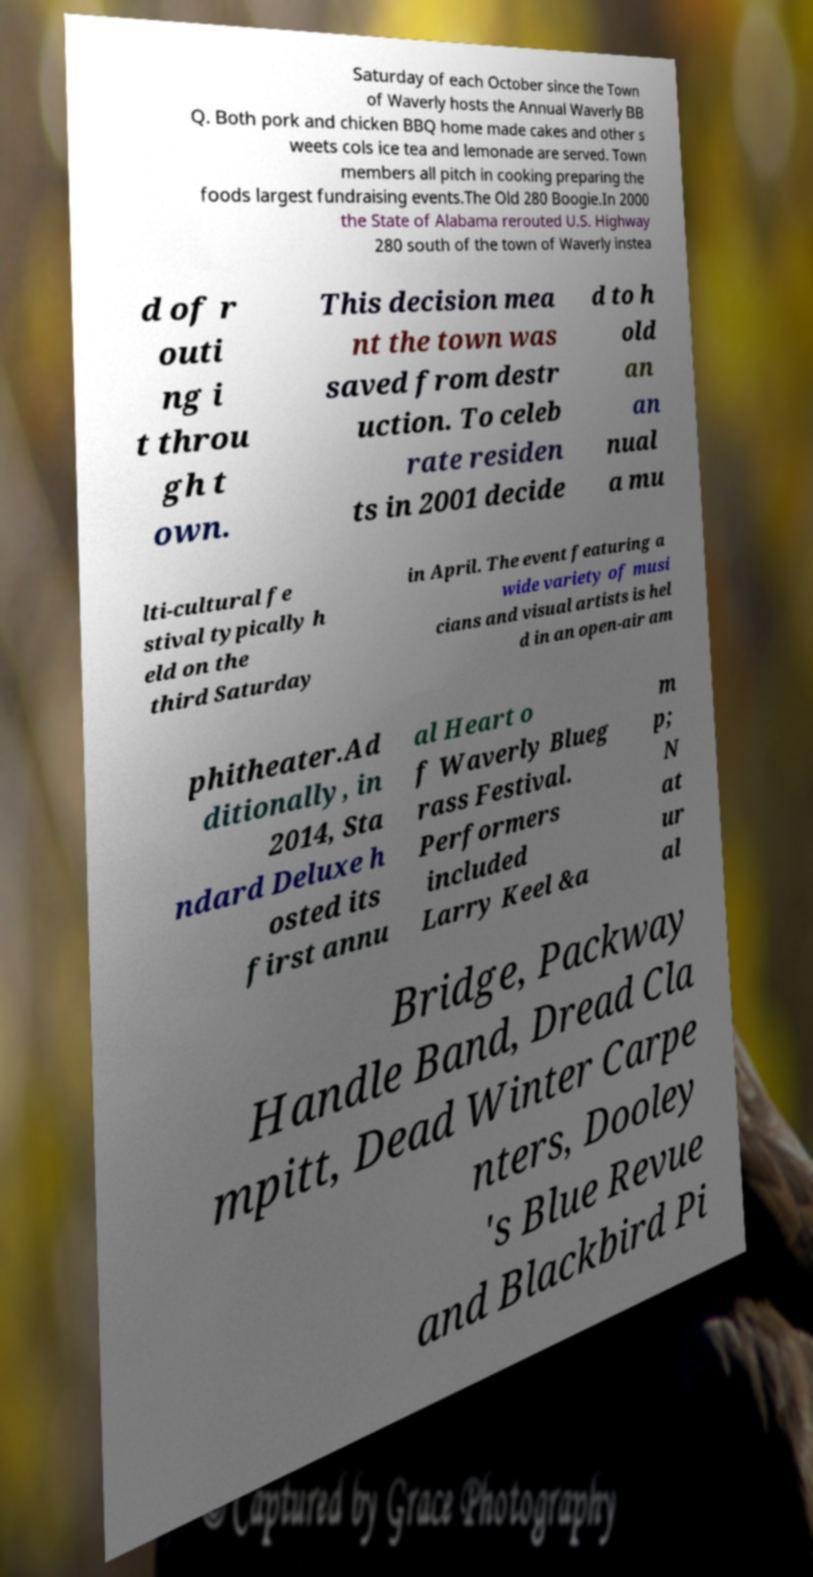There's text embedded in this image that I need extracted. Can you transcribe it verbatim? Saturday of each October since the Town of Waverly hosts the Annual Waverly BB Q. Both pork and chicken BBQ home made cakes and other s weets cols ice tea and lemonade are served. Town members all pitch in cooking preparing the foods largest fundraising events.The Old 280 Boogie.In 2000 the State of Alabama rerouted U.S. Highway 280 south of the town of Waverly instea d of r outi ng i t throu gh t own. This decision mea nt the town was saved from destr uction. To celeb rate residen ts in 2001 decide d to h old an an nual a mu lti-cultural fe stival typically h eld on the third Saturday in April. The event featuring a wide variety of musi cians and visual artists is hel d in an open-air am phitheater.Ad ditionally, in 2014, Sta ndard Deluxe h osted its first annu al Heart o f Waverly Blueg rass Festival. Performers included Larry Keel &a m p; N at ur al Bridge, Packway Handle Band, Dread Cla mpitt, Dead Winter Carpe nters, Dooley 's Blue Revue and Blackbird Pi 